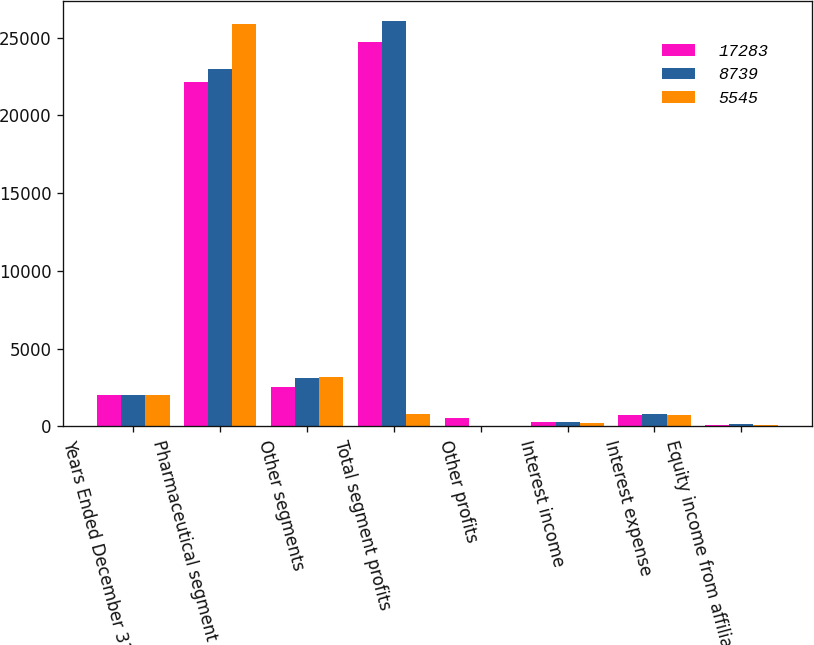Convert chart to OTSL. <chart><loc_0><loc_0><loc_500><loc_500><stacked_bar_chart><ecel><fcel>Years Ended December 31<fcel>Pharmaceutical segment<fcel>Other segments<fcel>Total segment profits<fcel>Other profits<fcel>Interest income<fcel>Interest expense<fcel>Equity income from affiliates<nl><fcel>17283<fcel>2014<fcel>22164<fcel>2546<fcel>24710<fcel>539<fcel>266<fcel>732<fcel>59<nl><fcel>8739<fcel>2013<fcel>22983<fcel>3094<fcel>26077<fcel>19<fcel>264<fcel>801<fcel>159<nl><fcel>5545<fcel>2012<fcel>25852<fcel>3163<fcel>801<fcel>26<fcel>232<fcel>714<fcel>102<nl></chart> 